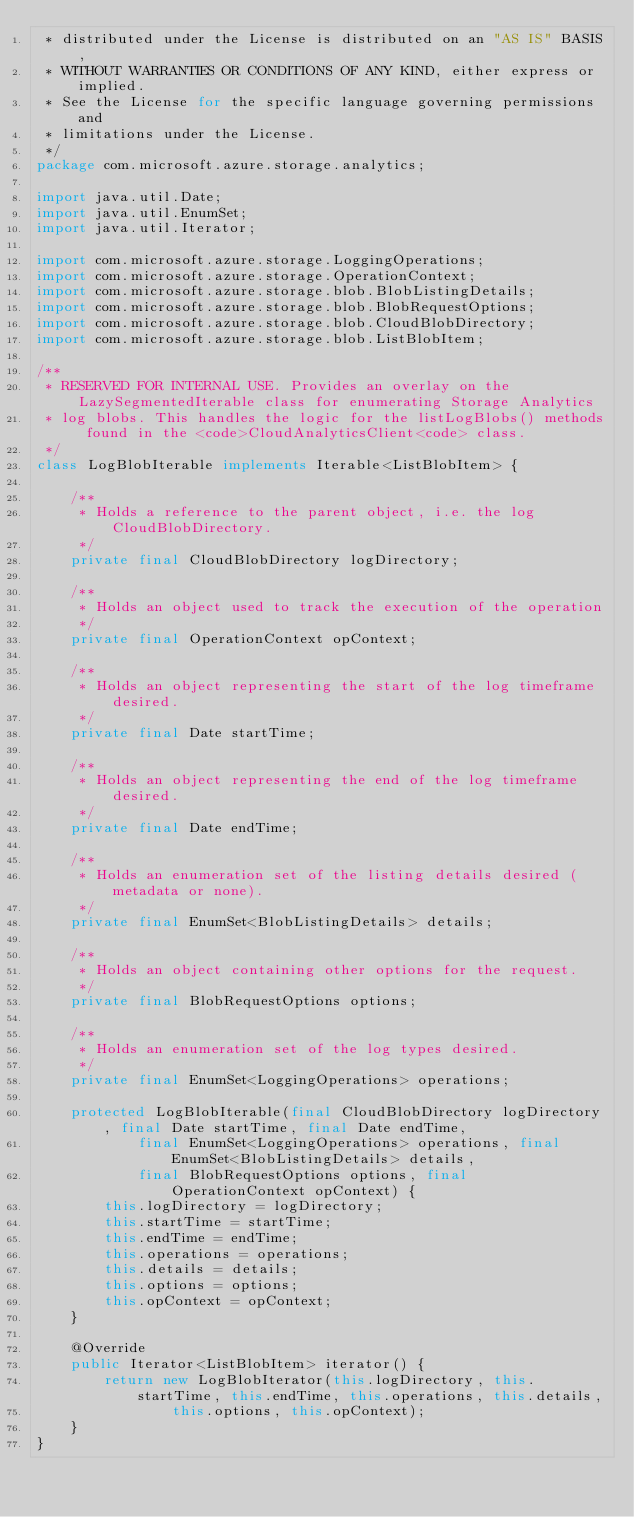Convert code to text. <code><loc_0><loc_0><loc_500><loc_500><_Java_> * distributed under the License is distributed on an "AS IS" BASIS,
 * WITHOUT WARRANTIES OR CONDITIONS OF ANY KIND, either express or implied.
 * See the License for the specific language governing permissions and
 * limitations under the License.
 */
package com.microsoft.azure.storage.analytics;

import java.util.Date;
import java.util.EnumSet;
import java.util.Iterator;

import com.microsoft.azure.storage.LoggingOperations;
import com.microsoft.azure.storage.OperationContext;
import com.microsoft.azure.storage.blob.BlobListingDetails;
import com.microsoft.azure.storage.blob.BlobRequestOptions;
import com.microsoft.azure.storage.blob.CloudBlobDirectory;
import com.microsoft.azure.storage.blob.ListBlobItem;

/**
 * RESERVED FOR INTERNAL USE. Provides an overlay on the LazySegmentedIterable class for enumerating Storage Analytics
 * log blobs. This handles the logic for the listLogBlobs() methods found in the <code>CloudAnalyticsClient<code> class.
 */
class LogBlobIterable implements Iterable<ListBlobItem> {

    /**
     * Holds a reference to the parent object, i.e. the log CloudBlobDirectory.
     */
    private final CloudBlobDirectory logDirectory;

    /**
     * Holds an object used to track the execution of the operation
     */
    private final OperationContext opContext;

    /**
     * Holds an object representing the start of the log timeframe desired.
     */
    private final Date startTime;

    /**
     * Holds an object representing the end of the log timeframe desired.
     */
    private final Date endTime;

    /**
     * Holds an enumeration set of the listing details desired (metadata or none).
     */
    private final EnumSet<BlobListingDetails> details;

    /**
     * Holds an object containing other options for the request.
     */
    private final BlobRequestOptions options;

    /**
     * Holds an enumeration set of the log types desired.
     */
    private final EnumSet<LoggingOperations> operations;

    protected LogBlobIterable(final CloudBlobDirectory logDirectory, final Date startTime, final Date endTime,
            final EnumSet<LoggingOperations> operations, final EnumSet<BlobListingDetails> details,
            final BlobRequestOptions options, final OperationContext opContext) {
        this.logDirectory = logDirectory;
        this.startTime = startTime;
        this.endTime = endTime;
        this.operations = operations;
        this.details = details;
        this.options = options;
        this.opContext = opContext;
    }

    @Override
    public Iterator<ListBlobItem> iterator() {
        return new LogBlobIterator(this.logDirectory, this.startTime, this.endTime, this.operations, this.details,
                this.options, this.opContext);
    }
}
</code> 